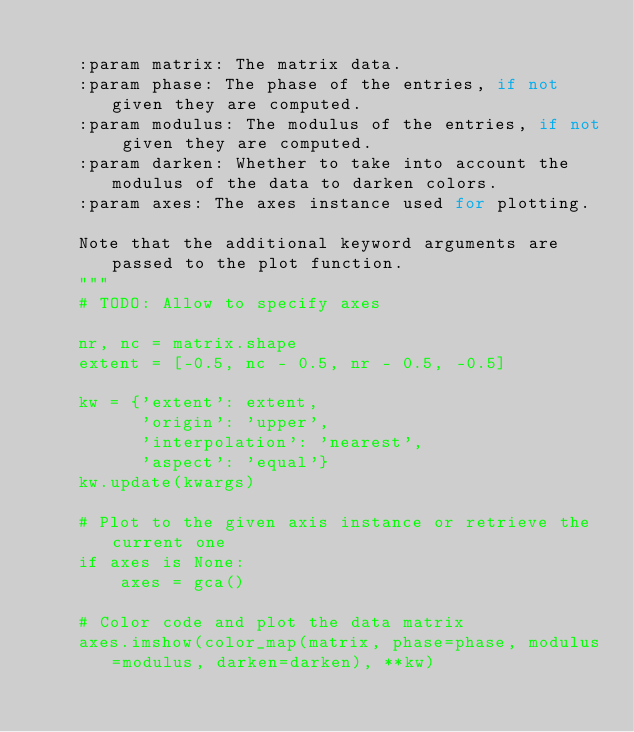Convert code to text. <code><loc_0><loc_0><loc_500><loc_500><_Python_>
    :param matrix: The matrix data.
    :param phase: The phase of the entries, if not given they are computed.
    :param modulus: The modulus of the entries, if not given they are computed.
    :param darken: Whether to take into account the modulus of the data to darken colors.
    :param axes: The axes instance used for plotting.

    Note that the additional keyword arguments are passed to the plot function.
    """
    # TODO: Allow to specify axes

    nr, nc = matrix.shape
    extent = [-0.5, nc - 0.5, nr - 0.5, -0.5]

    kw = {'extent': extent,
          'origin': 'upper',
          'interpolation': 'nearest',
          'aspect': 'equal'}
    kw.update(kwargs)

    # Plot to the given axis instance or retrieve the current one
    if axes is None:
        axes = gca()

    # Color code and plot the data matrix
    axes.imshow(color_map(matrix, phase=phase, modulus=modulus, darken=darken), **kw)
</code> 